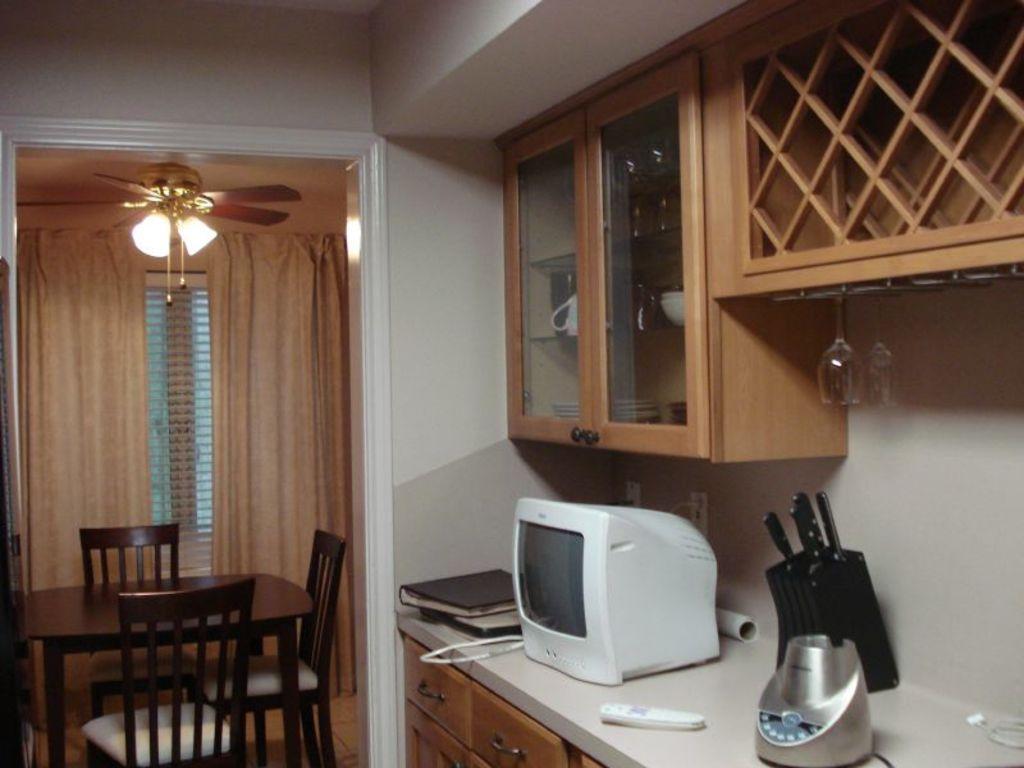Describe this image in one or two sentences. This is a picture of inside of the house, in this picture on the left side there is a table and chairs and curtains, fan. On the right side there is one monitor, remote, knives, mixer grinder and some books on a table. And at the bottom there is a cupboard and at the top there are cupboards, in the cupboards there are some cups and some objects and in the center there is a wall. At the bottom there is floor. 